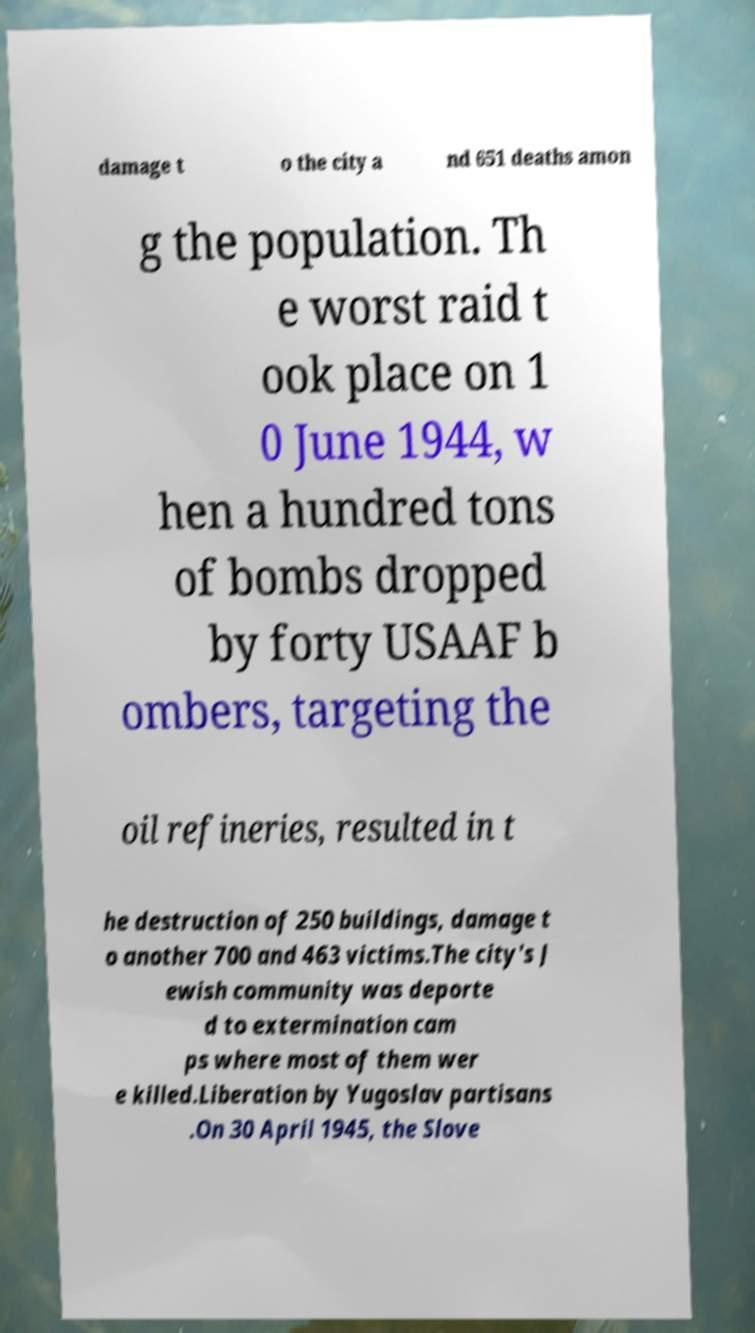Can you read and provide the text displayed in the image?This photo seems to have some interesting text. Can you extract and type it out for me? damage t o the city a nd 651 deaths amon g the population. Th e worst raid t ook place on 1 0 June 1944, w hen a hundred tons of bombs dropped by forty USAAF b ombers, targeting the oil refineries, resulted in t he destruction of 250 buildings, damage t o another 700 and 463 victims.The city's J ewish community was deporte d to extermination cam ps where most of them wer e killed.Liberation by Yugoslav partisans .On 30 April 1945, the Slove 